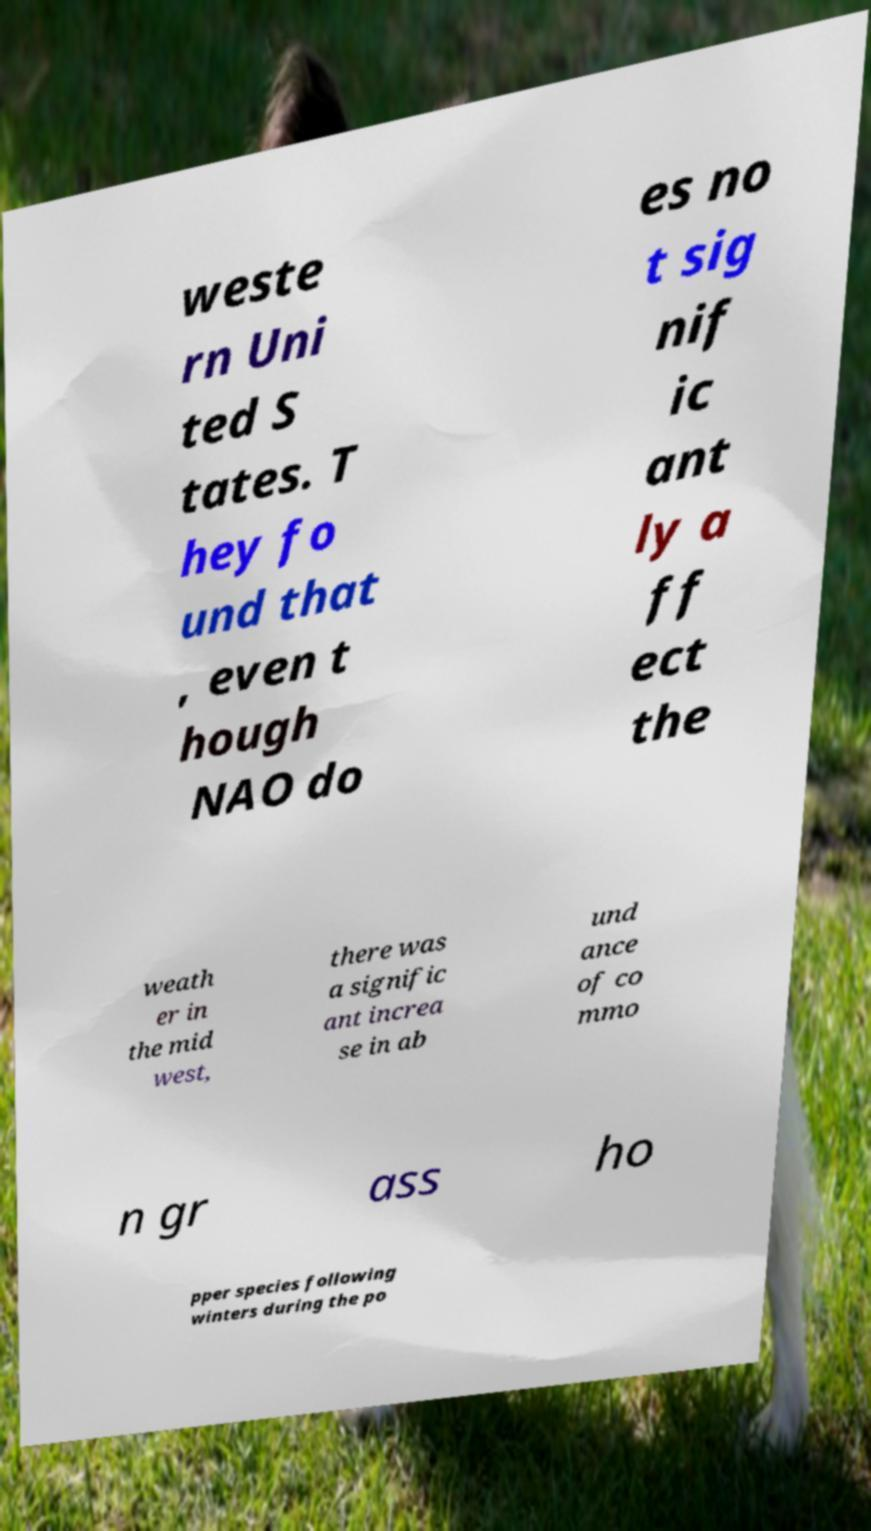Please identify and transcribe the text found in this image. weste rn Uni ted S tates. T hey fo und that , even t hough NAO do es no t sig nif ic ant ly a ff ect the weath er in the mid west, there was a signific ant increa se in ab und ance of co mmo n gr ass ho pper species following winters during the po 